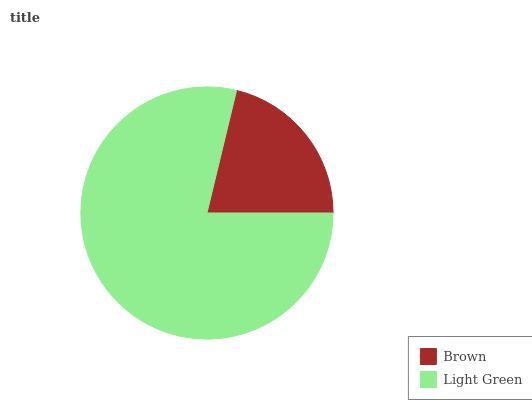Is Brown the minimum?
Answer yes or no. Yes. Is Light Green the maximum?
Answer yes or no. Yes. Is Light Green the minimum?
Answer yes or no. No. Is Light Green greater than Brown?
Answer yes or no. Yes. Is Brown less than Light Green?
Answer yes or no. Yes. Is Brown greater than Light Green?
Answer yes or no. No. Is Light Green less than Brown?
Answer yes or no. No. Is Light Green the high median?
Answer yes or no. Yes. Is Brown the low median?
Answer yes or no. Yes. Is Brown the high median?
Answer yes or no. No. Is Light Green the low median?
Answer yes or no. No. 